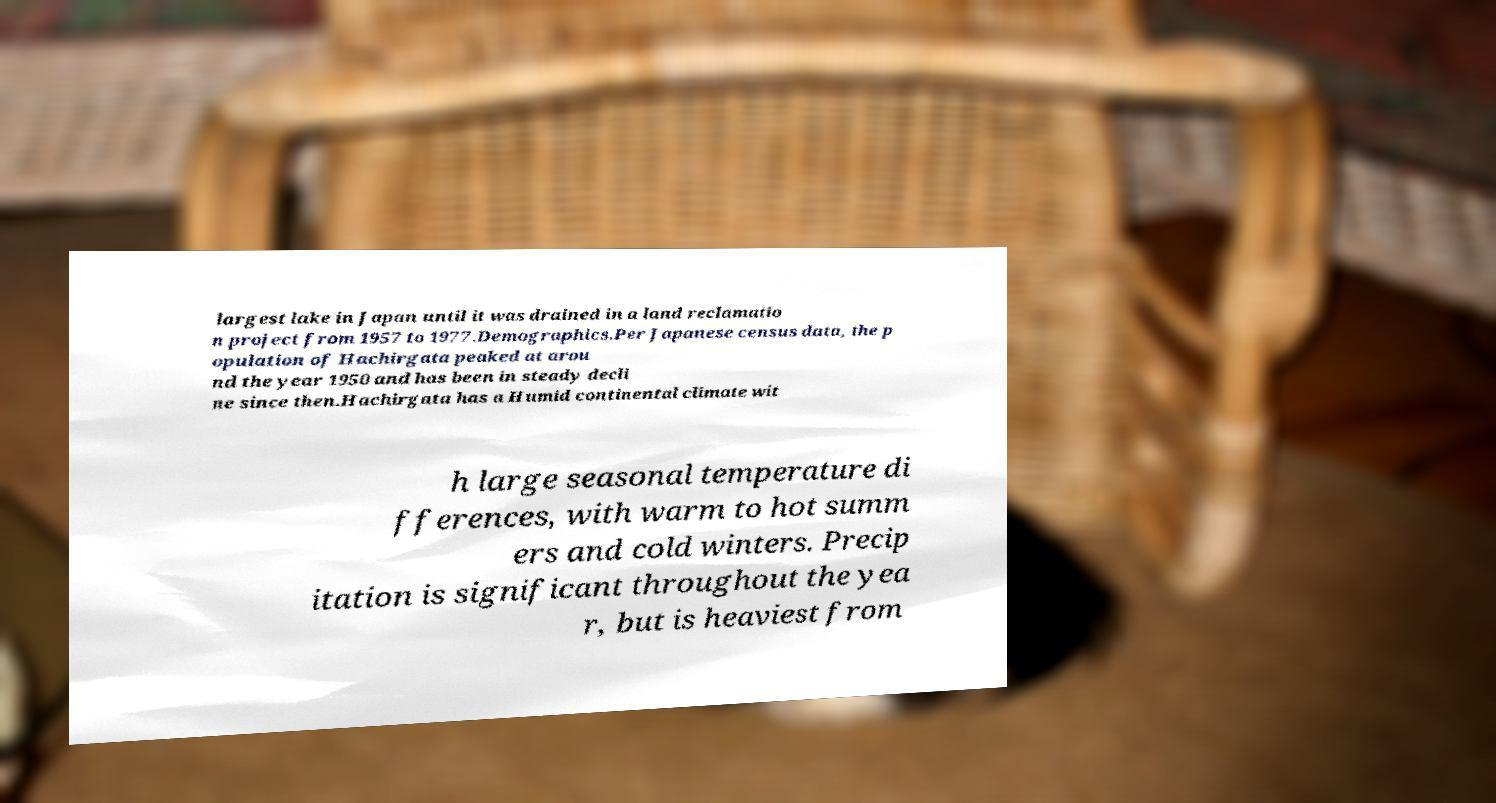What messages or text are displayed in this image? I need them in a readable, typed format. largest lake in Japan until it was drained in a land reclamatio n project from 1957 to 1977.Demographics.Per Japanese census data, the p opulation of Hachirgata peaked at arou nd the year 1950 and has been in steady decli ne since then.Hachirgata has a Humid continental climate wit h large seasonal temperature di fferences, with warm to hot summ ers and cold winters. Precip itation is significant throughout the yea r, but is heaviest from 